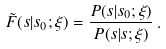Convert formula to latex. <formula><loc_0><loc_0><loc_500><loc_500>\tilde { F } ( s | s _ { 0 } ; \xi ) = \frac { P ( s | s _ { 0 } ; \xi ) } { P ( s | s ; \xi ) } \, .</formula> 